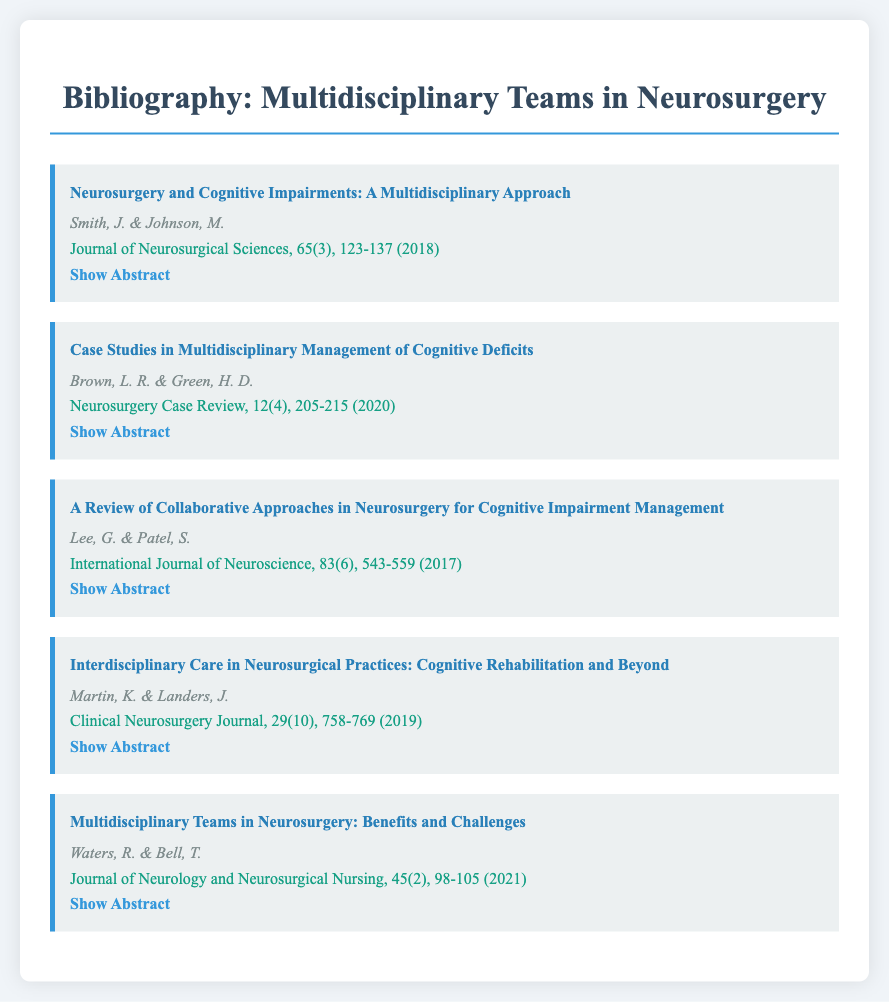what is the title of the first bibliography item? The title of the first bibliography item is provided in the document under "title."
Answer: Neurosurgery and Cognitive Impairments: A Multidisciplinary Approach who are the authors of the article published in 2020? The authors are listed under each bibliography item; the 2020 publication lists the authors directly.
Answer: Brown, L. R. & Green, H. D which journal published the article about interdisciplinary care in 2019? The journal is mentioned in the citation of each bibliography item, specifying the source.
Answer: Clinical Neurosurgery Journal how many pages does the article by Lee and Patel cover? The number of pages is included in the journal citation for each item, represented as the last part of the citation.
Answer: 543-559 what is the main focus of the article by Smith and Johnson? The abstract summarizes the key topic discussed in the article.
Answer: Managing cognitive impairments which year was the article discussing the challenges of multidisciplinary teams published? The year is part of the citation for each article, indicating when it was published.
Answer: 2021 what is the volume number of the article published by Lee and Patel? The volume number is included in the journal citation format.
Answer: 83 what type of research does the article by Martin and Landers primarily explore? The type of research is specified in the title and abstract of the article.
Answer: Cognitive rehabilitation 